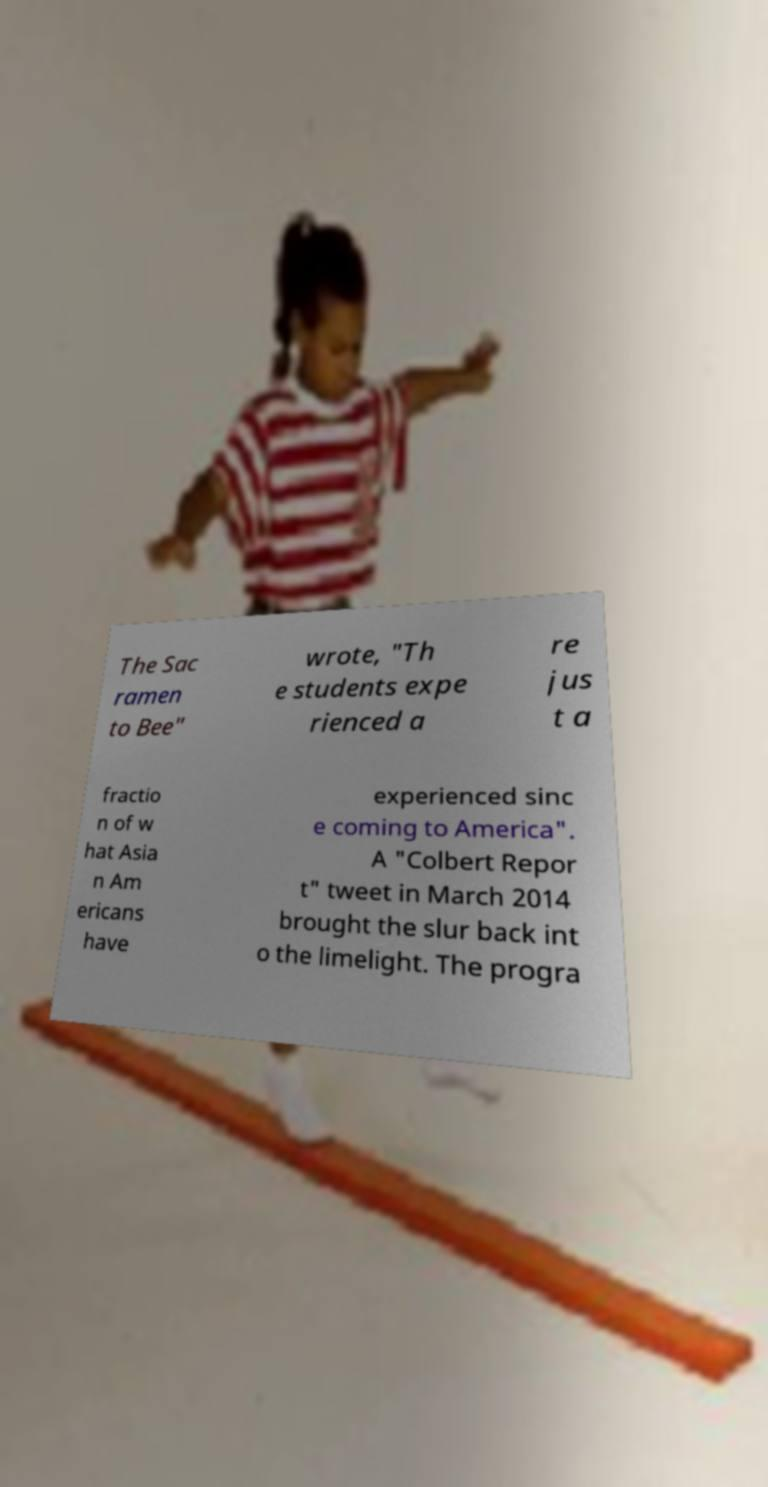Please identify and transcribe the text found in this image. The Sac ramen to Bee" wrote, "Th e students expe rienced a re jus t a fractio n of w hat Asia n Am ericans have experienced sinc e coming to America". A "Colbert Repor t" tweet in March 2014 brought the slur back int o the limelight. The progra 